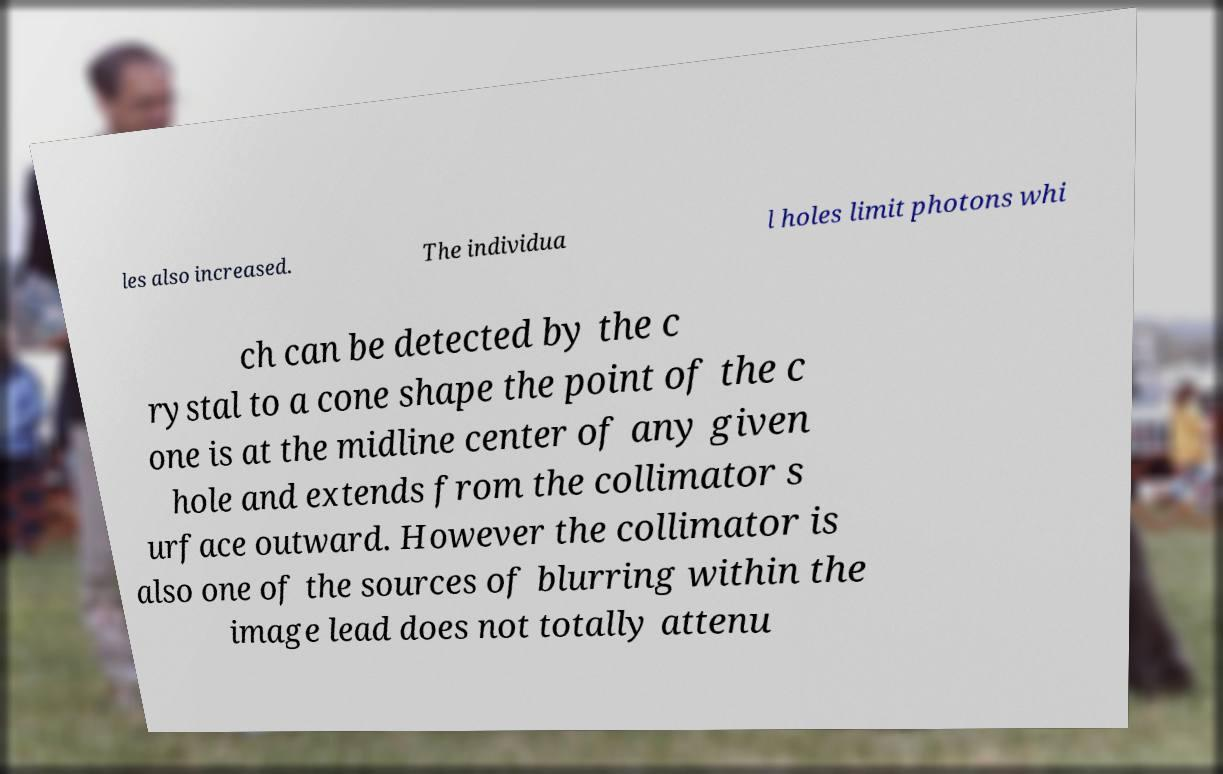For documentation purposes, I need the text within this image transcribed. Could you provide that? les also increased. The individua l holes limit photons whi ch can be detected by the c rystal to a cone shape the point of the c one is at the midline center of any given hole and extends from the collimator s urface outward. However the collimator is also one of the sources of blurring within the image lead does not totally attenu 